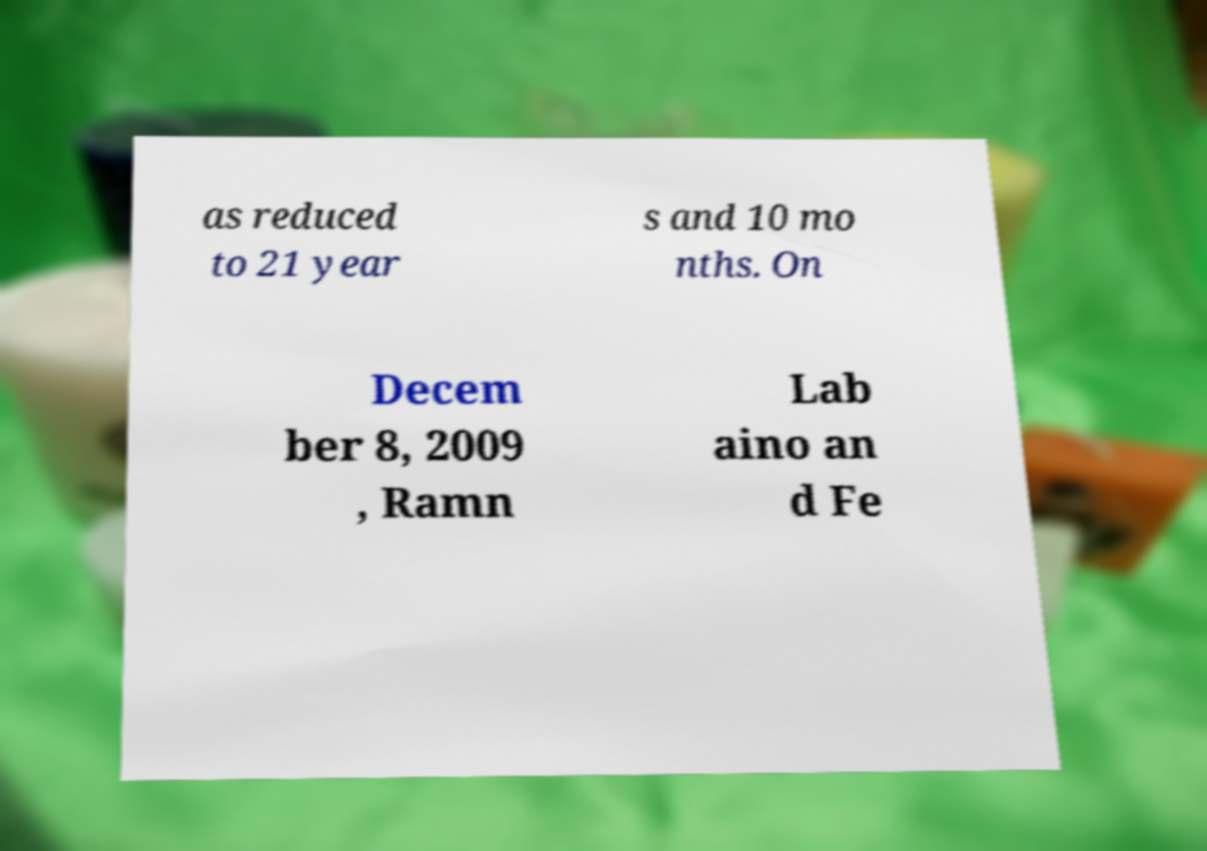Can you accurately transcribe the text from the provided image for me? as reduced to 21 year s and 10 mo nths. On Decem ber 8, 2009 , Ramn Lab aino an d Fe 